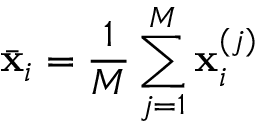Convert formula to latex. <formula><loc_0><loc_0><loc_500><loc_500>\ B a r { x } _ { i } = \frac { 1 } { M } \sum _ { j = 1 } ^ { M } x _ { i } ^ { ( j ) }</formula> 